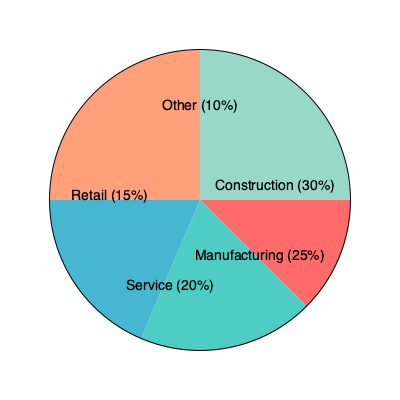Based on the pie chart showing job sectors employing ex-offenders, what percentage of ex-offenders would be employed in the Construction and Manufacturing sectors combined? To determine the percentage of ex-offenders employed in the Construction and Manufacturing sectors combined, we need to:

1. Identify the percentages for each sector:
   - Construction: 30%
   - Manufacturing: 25%

2. Add these percentages together:
   $30\% + 25\% = 55\%$

3. Verify the result:
   - The sum of all sectors should equal 100%
   - Construction (30%) + Manufacturing (25%) + Service (20%) + Retail (15%) + Other (10%) = 100%

4. Interpret the result:
   55% of ex-offenders would be employed in the Construction and Manufacturing sectors combined.

This high percentage (over half) in these two sectors suggests that they are significant employers of ex-offenders, potentially due to labor shortages, less stringent background check requirements, or specific skills programs aimed at rehabilitation.
Answer: 55% 